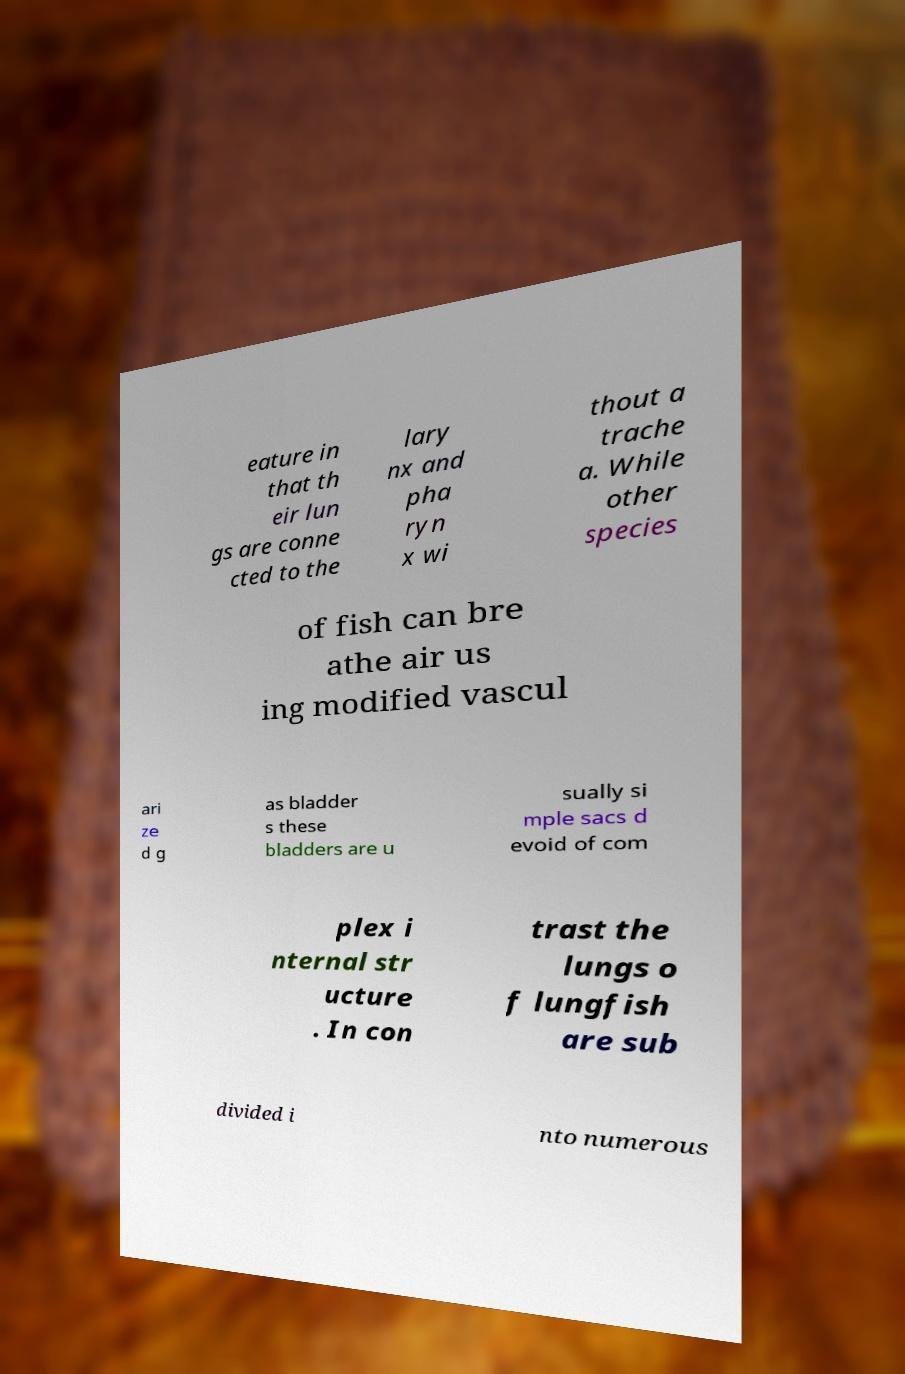There's text embedded in this image that I need extracted. Can you transcribe it verbatim? eature in that th eir lun gs are conne cted to the lary nx and pha ryn x wi thout a trache a. While other species of fish can bre athe air us ing modified vascul ari ze d g as bladder s these bladders are u sually si mple sacs d evoid of com plex i nternal str ucture . In con trast the lungs o f lungfish are sub divided i nto numerous 